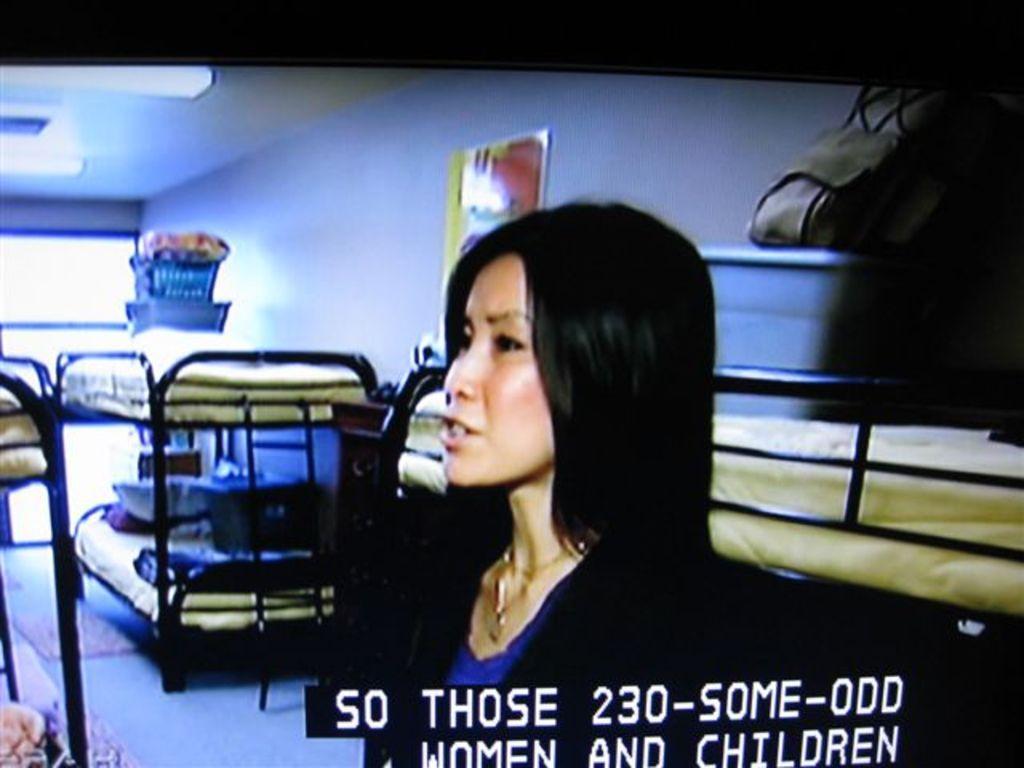How would you summarize this image in a sentence or two? There is a woman. In the back there are many cots with beds. Also there is a wall with a photo frame. On the ceiling there are lights. On the bed there are baskets and something is written on the image. 